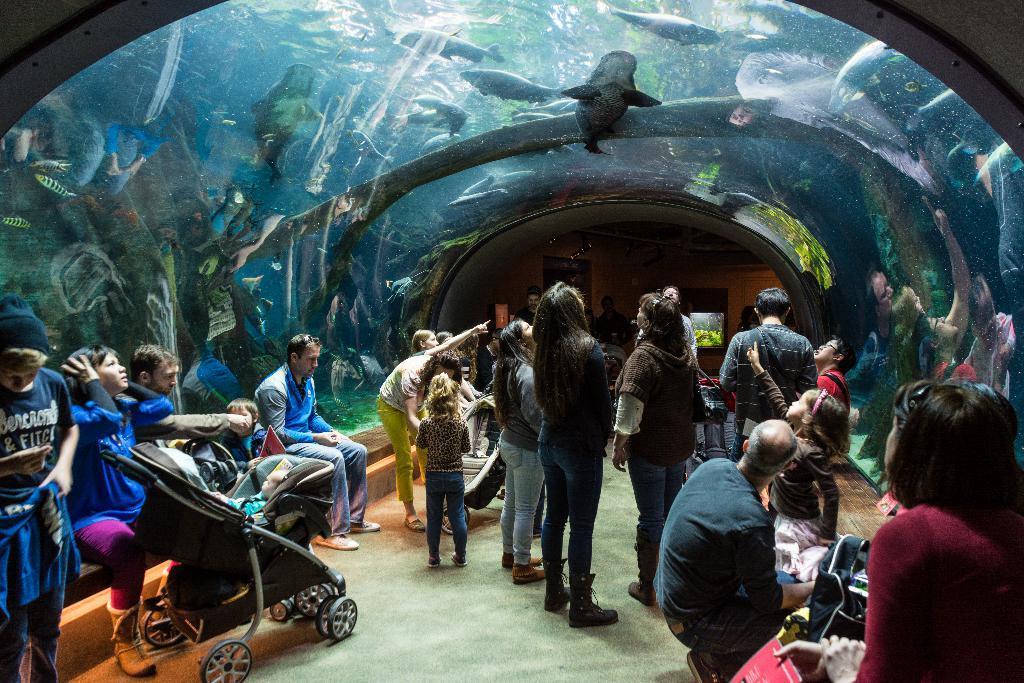In one or two sentences, can you explain what this image depicts? Some people are watching the fish in an underwater aquarium. There are wide variety of fish in the aquarium. 